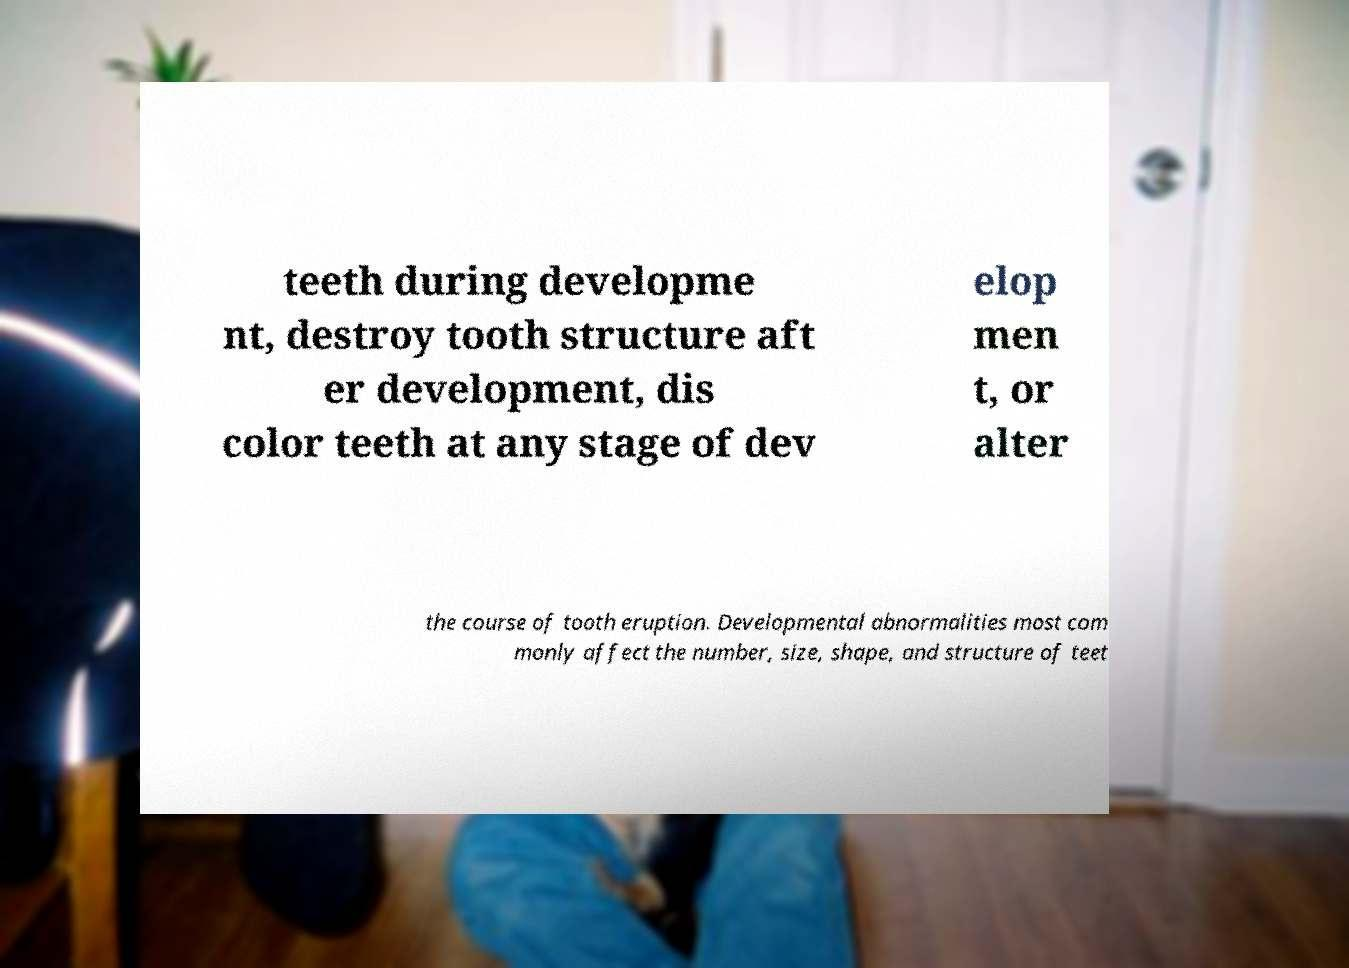For documentation purposes, I need the text within this image transcribed. Could you provide that? teeth during developme nt, destroy tooth structure aft er development, dis color teeth at any stage of dev elop men t, or alter the course of tooth eruption. Developmental abnormalities most com monly affect the number, size, shape, and structure of teet 